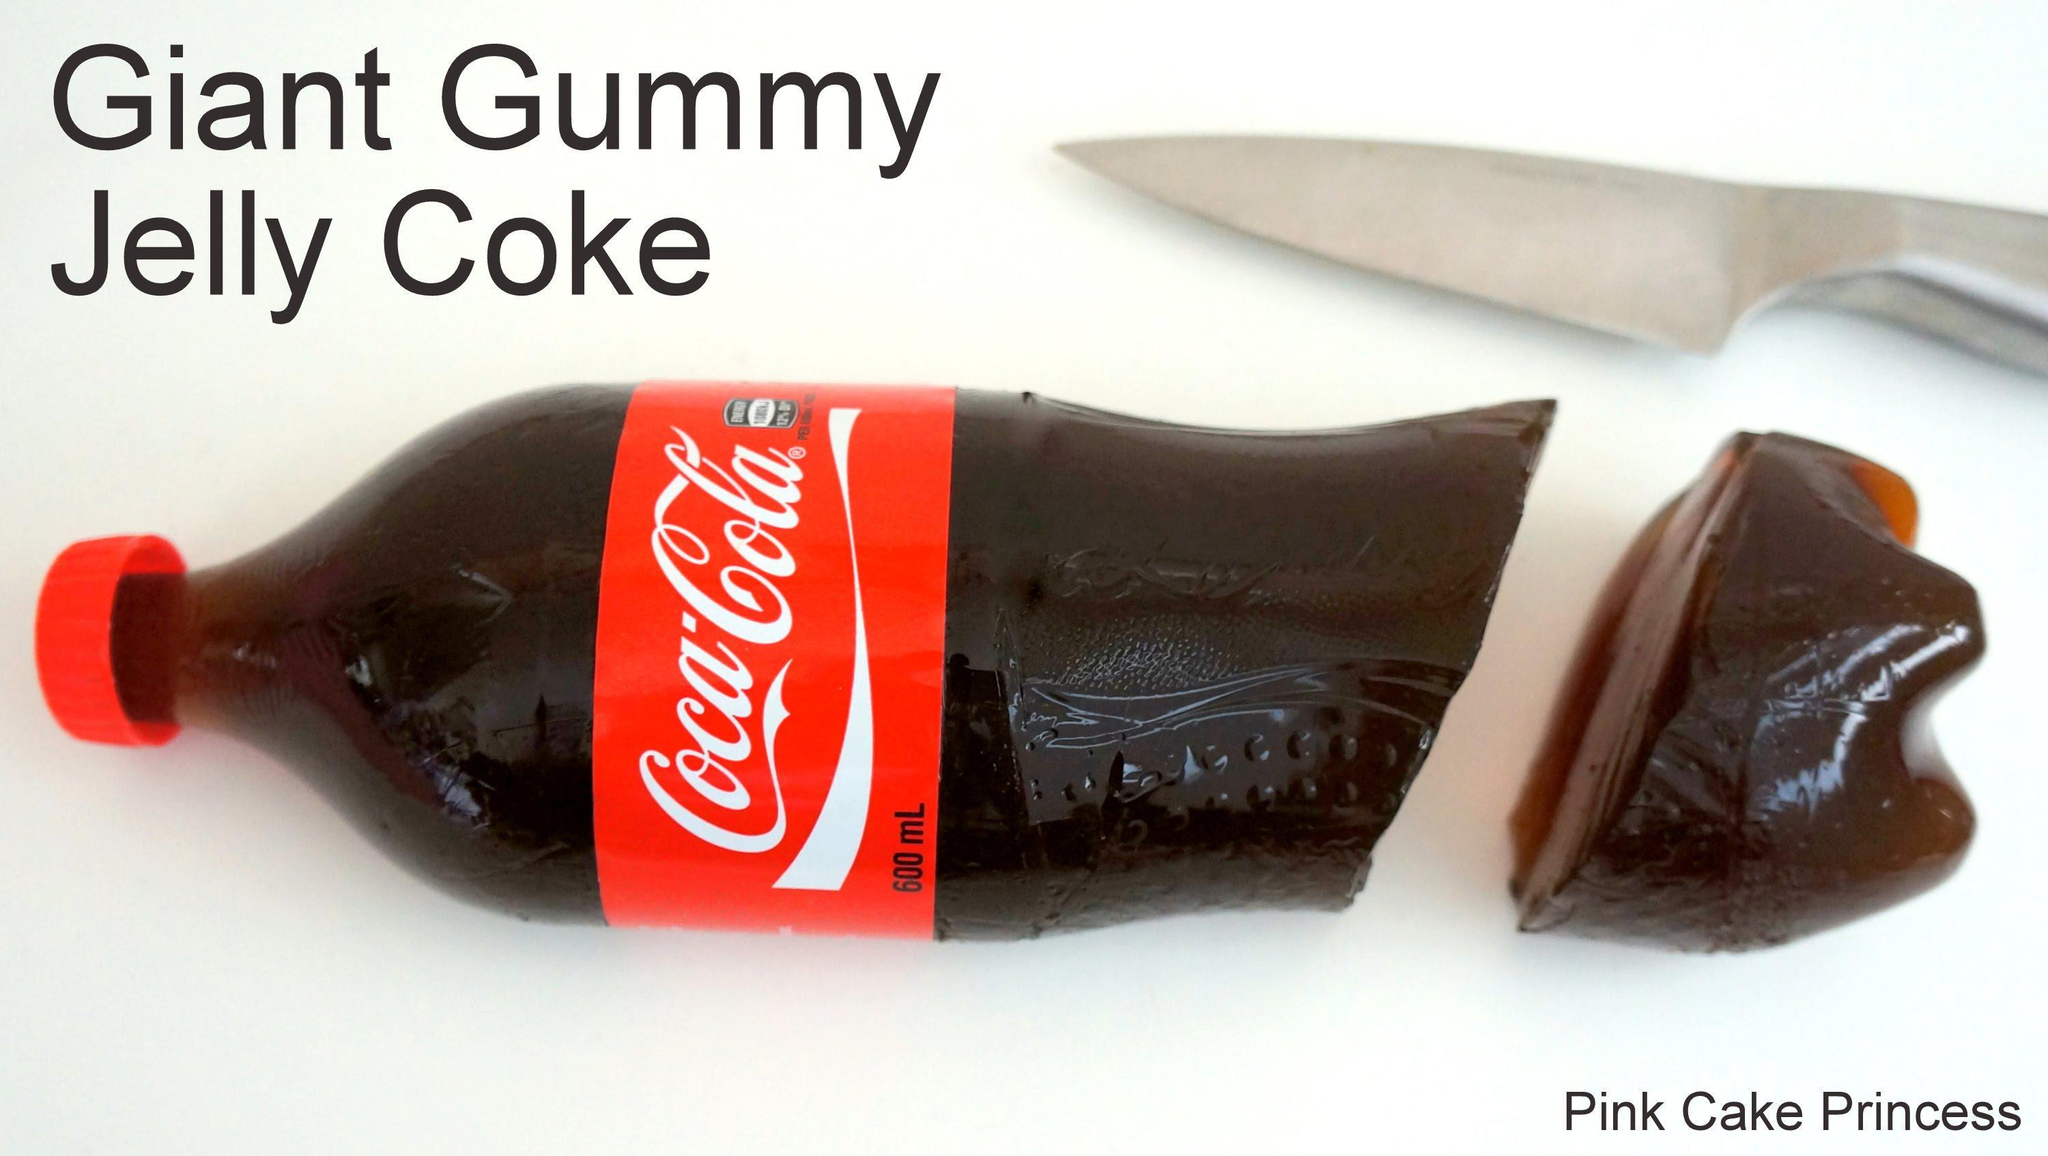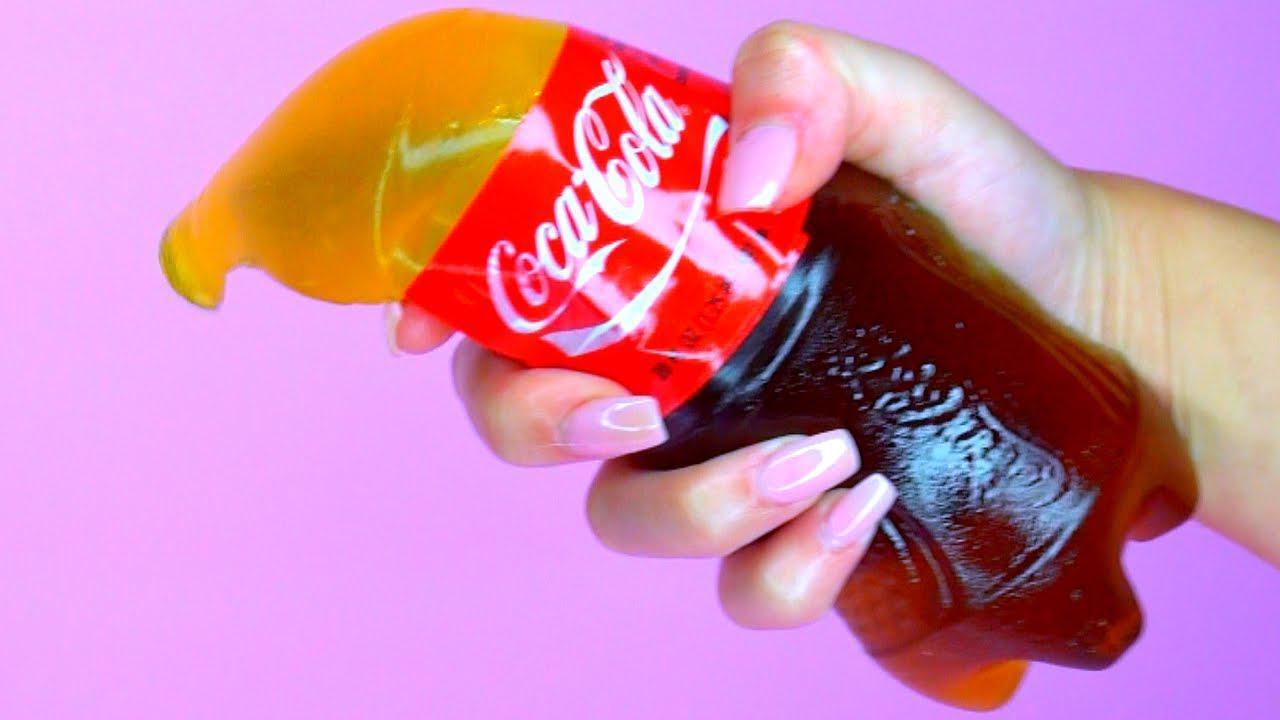The first image is the image on the left, the second image is the image on the right. Evaluate the accuracy of this statement regarding the images: "One image includes a silver-bladed knife and a bottle shape that is cut in two separated parts, and a hand is grasping a bottle that is not split in two parts in the other image.". Is it true? Answer yes or no. Yes. 